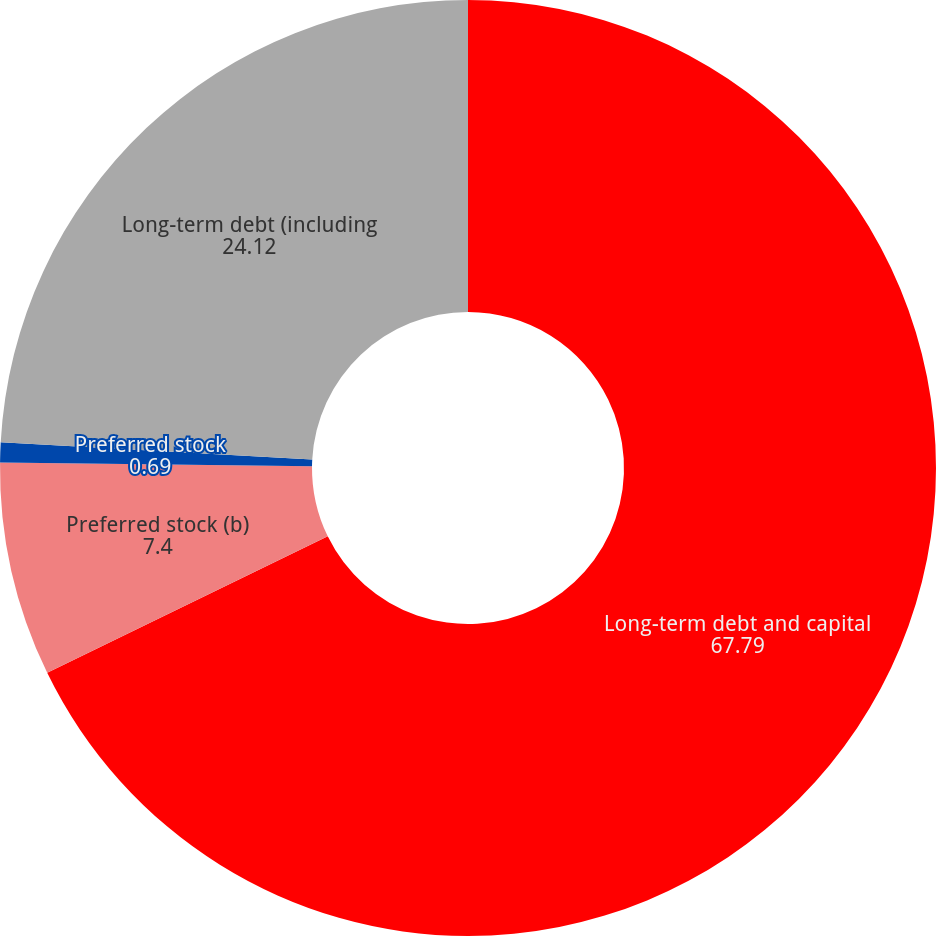Convert chart to OTSL. <chart><loc_0><loc_0><loc_500><loc_500><pie_chart><fcel>Long-term debt and capital<fcel>Preferred stock (b)<fcel>Preferred stock<fcel>Long-term debt (including<nl><fcel>67.79%<fcel>7.4%<fcel>0.69%<fcel>24.12%<nl></chart> 